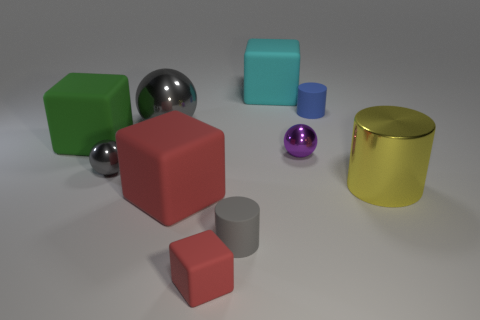Is the number of things to the right of the blue thing less than the number of blue matte objects that are on the left side of the cyan object?
Your response must be concise. No. There is a gray object that is behind the purple shiny object; how big is it?
Ensure brevity in your answer.  Large. Is the cyan rubber cube the same size as the metal cylinder?
Offer a very short reply. Yes. How many tiny rubber cylinders are both right of the purple metal sphere and in front of the blue cylinder?
Your answer should be compact. 0. What number of purple things are either tiny rubber blocks or objects?
Make the answer very short. 1. How many matte objects are either large yellow blocks or cyan cubes?
Give a very brief answer. 1. Are any green shiny cylinders visible?
Your answer should be very brief. No. Does the big yellow thing have the same shape as the blue object?
Give a very brief answer. Yes. There is a red block that is in front of the cylinder in front of the metallic cylinder; how many tiny objects are right of it?
Offer a very short reply. 3. What material is the tiny thing that is both behind the tiny red thing and to the left of the small gray rubber thing?
Make the answer very short. Metal. 